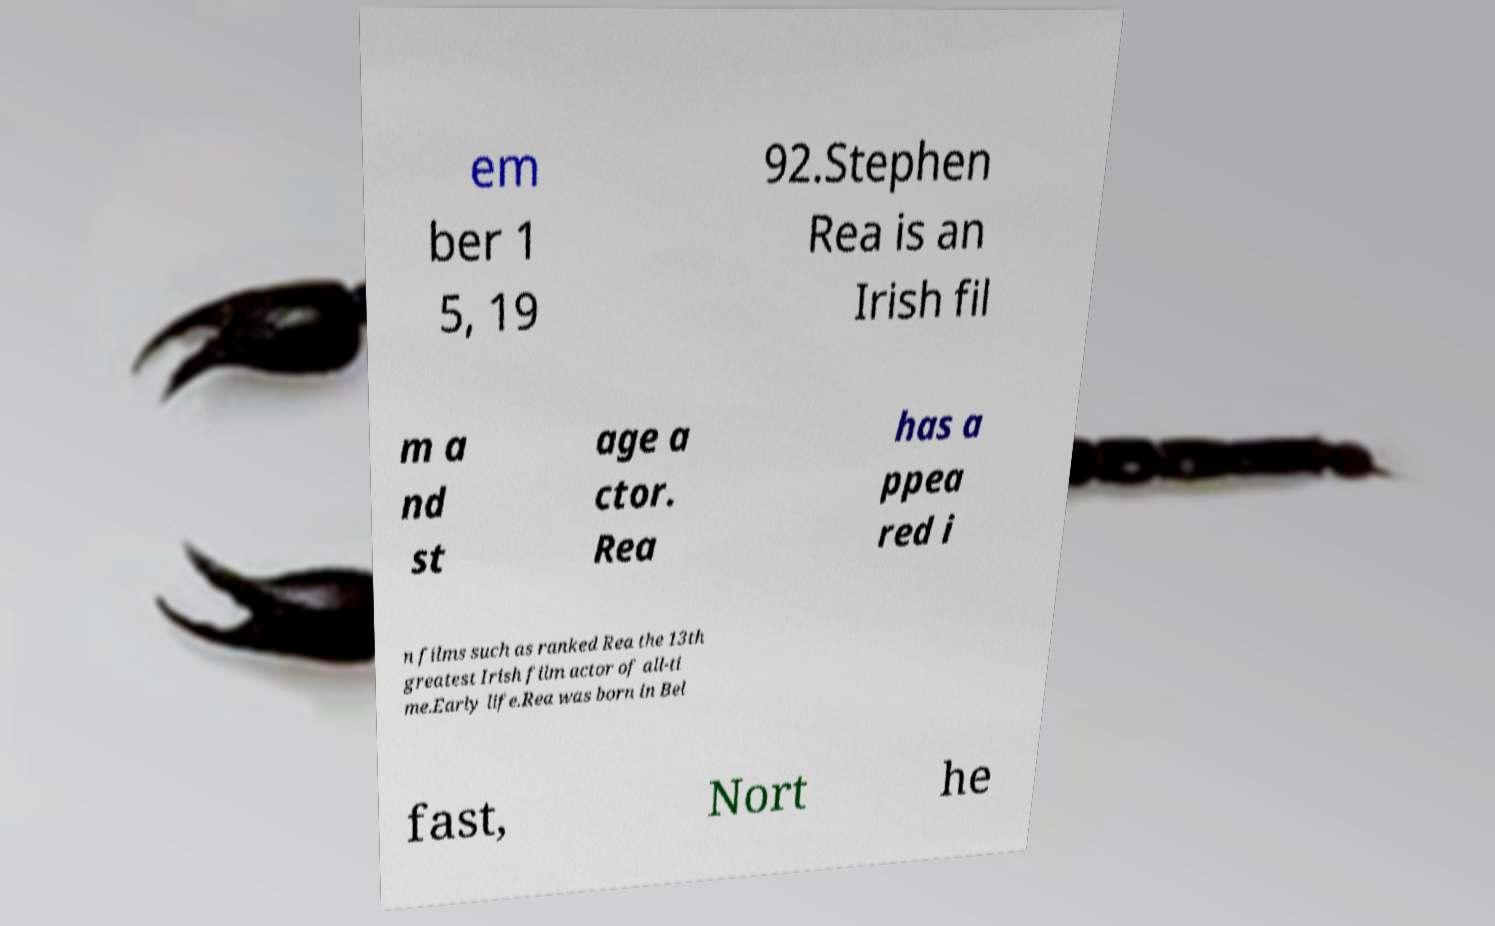What messages or text are displayed in this image? I need them in a readable, typed format. em ber 1 5, 19 92.Stephen Rea is an Irish fil m a nd st age a ctor. Rea has a ppea red i n films such as ranked Rea the 13th greatest Irish film actor of all-ti me.Early life.Rea was born in Bel fast, Nort he 